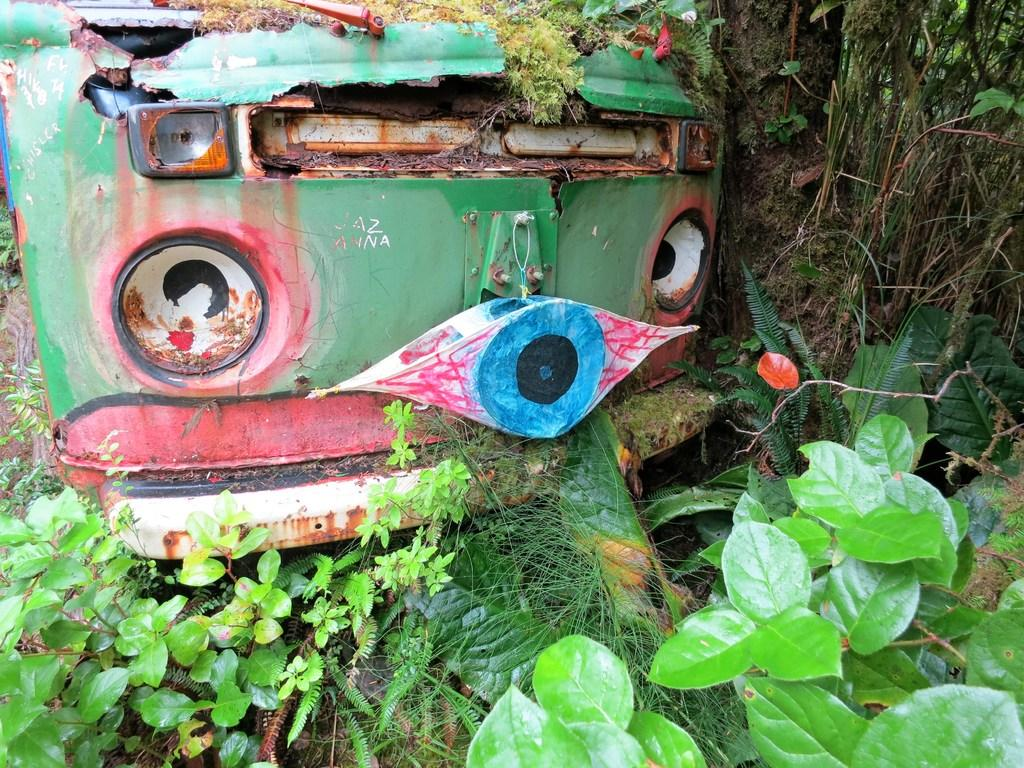What is the main subject in the center of the image? There is a vehicle in the center of the image. What type of vegetation can be seen on the right side of the image? There are trees on the right side of the image. What is present at the bottom of the image? There are plants and grass at the bottom of the image. How many beds are visible in the image? There are no beds present in the image. What type of seat is available for the driver of the vehicle in the image? The image does not show the interior of the vehicle, so it is impossible to determine if there is a seat for the driver. 